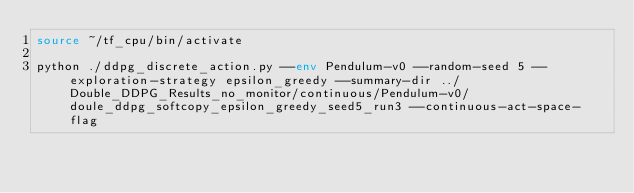<code> <loc_0><loc_0><loc_500><loc_500><_Bash_>source ~/tf_cpu/bin/activate

python ./ddpg_discrete_action.py --env Pendulum-v0 --random-seed 5 --exploration-strategy epsilon_greedy --summary-dir ../Double_DDPG_Results_no_monitor/continuous/Pendulum-v0/doule_ddpg_softcopy_epsilon_greedy_seed5_run3 --continuous-act-space-flag   

</code> 